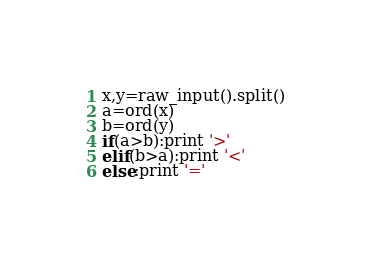Convert code to text. <code><loc_0><loc_0><loc_500><loc_500><_Python_>x,y=raw_input().split()
a=ord(x)
b=ord(y)
if(a>b):print '>'
elif(b>a):print '<'
else:print '='</code> 